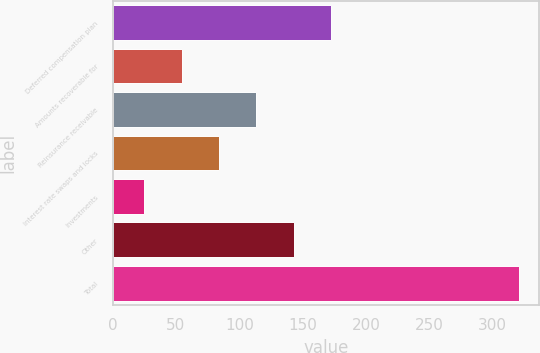Convert chart to OTSL. <chart><loc_0><loc_0><loc_500><loc_500><bar_chart><fcel>Deferred compensation plan<fcel>Amounts recoverable for<fcel>Reinsurance receivable<fcel>Interest rate swaps and locks<fcel>Investments<fcel>Other<fcel>Total<nl><fcel>172.65<fcel>54.37<fcel>113.51<fcel>83.94<fcel>24.8<fcel>143.08<fcel>320.5<nl></chart> 